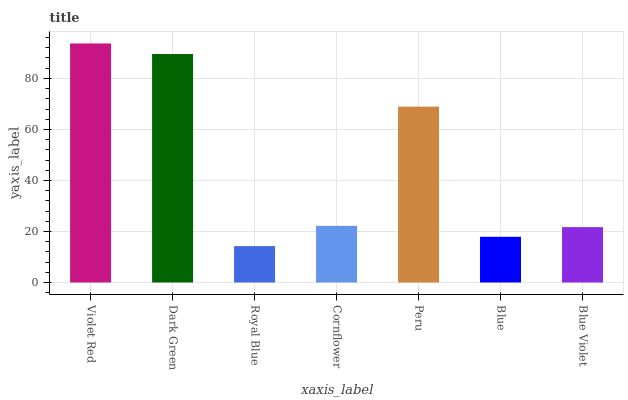Is Royal Blue the minimum?
Answer yes or no. Yes. Is Violet Red the maximum?
Answer yes or no. Yes. Is Dark Green the minimum?
Answer yes or no. No. Is Dark Green the maximum?
Answer yes or no. No. Is Violet Red greater than Dark Green?
Answer yes or no. Yes. Is Dark Green less than Violet Red?
Answer yes or no. Yes. Is Dark Green greater than Violet Red?
Answer yes or no. No. Is Violet Red less than Dark Green?
Answer yes or no. No. Is Cornflower the high median?
Answer yes or no. Yes. Is Cornflower the low median?
Answer yes or no. Yes. Is Blue Violet the high median?
Answer yes or no. No. Is Dark Green the low median?
Answer yes or no. No. 